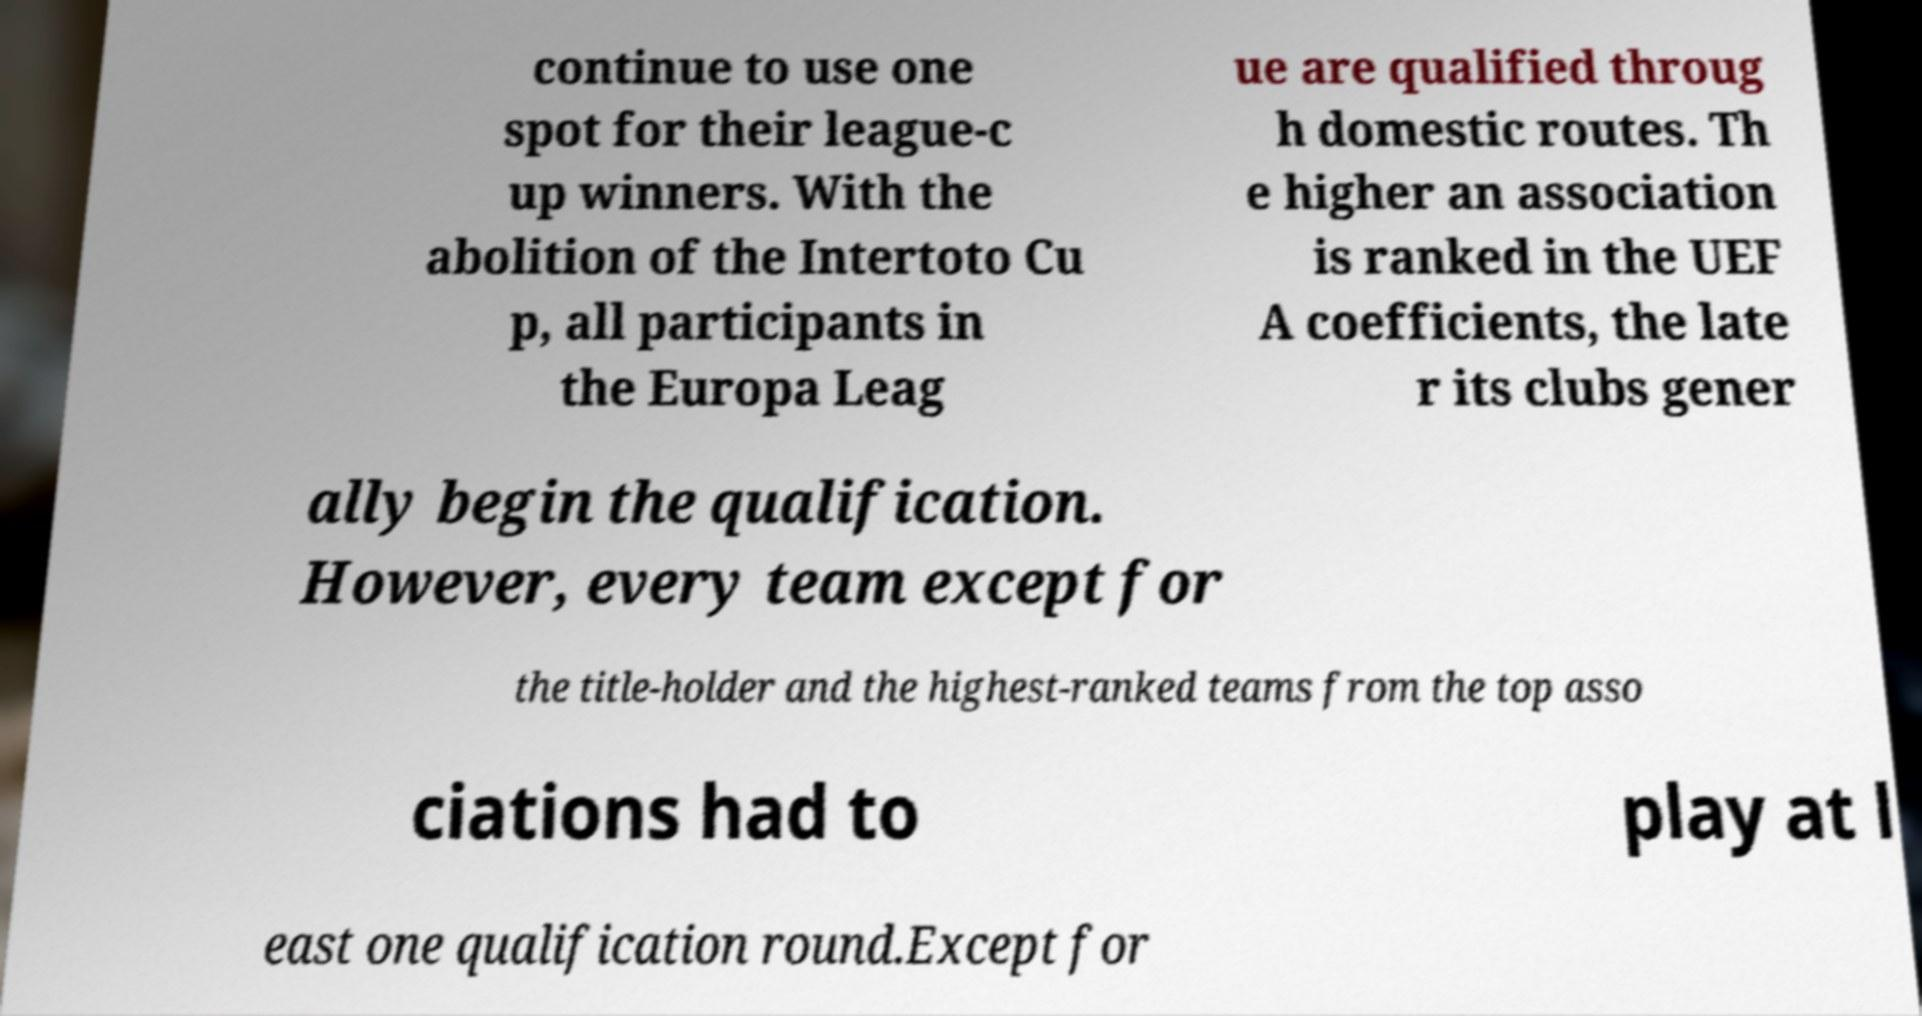Can you accurately transcribe the text from the provided image for me? continue to use one spot for their league-c up winners. With the abolition of the Intertoto Cu p, all participants in the Europa Leag ue are qualified throug h domestic routes. Th e higher an association is ranked in the UEF A coefficients, the late r its clubs gener ally begin the qualification. However, every team except for the title-holder and the highest-ranked teams from the top asso ciations had to play at l east one qualification round.Except for 